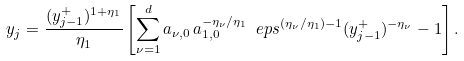Convert formula to latex. <formula><loc_0><loc_0><loc_500><loc_500>y _ { j } = \frac { ( y ^ { + } _ { j - 1 } ) ^ { 1 + \eta _ { 1 } } } { \eta _ { 1 } } \left [ \sum _ { \nu = 1 } ^ { d } a _ { \nu , 0 } \, a _ { 1 , 0 } ^ { - \eta _ { \nu } / \eta _ { 1 } } \ e p s ^ { ( \eta _ { \nu } / \eta _ { 1 } ) - 1 } ( y ^ { + } _ { j - 1 } ) ^ { - \eta _ { \nu } } - 1 \right ] .</formula> 